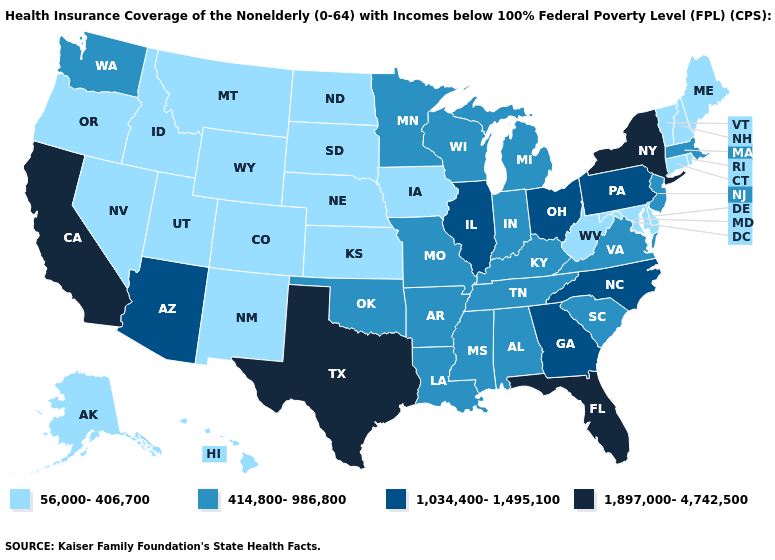What is the highest value in states that border Indiana?
Quick response, please. 1,034,400-1,495,100. Which states have the lowest value in the South?
Quick response, please. Delaware, Maryland, West Virginia. What is the lowest value in the Northeast?
Be succinct. 56,000-406,700. What is the value of West Virginia?
Write a very short answer. 56,000-406,700. How many symbols are there in the legend?
Give a very brief answer. 4. Which states hav the highest value in the South?
Give a very brief answer. Florida, Texas. Which states hav the highest value in the Northeast?
Give a very brief answer. New York. Does Idaho have the highest value in the West?
Keep it brief. No. Does the first symbol in the legend represent the smallest category?
Answer briefly. Yes. What is the lowest value in the South?
Quick response, please. 56,000-406,700. Name the states that have a value in the range 1,034,400-1,495,100?
Short answer required. Arizona, Georgia, Illinois, North Carolina, Ohio, Pennsylvania. Which states have the highest value in the USA?
Give a very brief answer. California, Florida, New York, Texas. What is the lowest value in the Northeast?
Quick response, please. 56,000-406,700. What is the value of North Dakota?
Keep it brief. 56,000-406,700. What is the value of Pennsylvania?
Keep it brief. 1,034,400-1,495,100. 